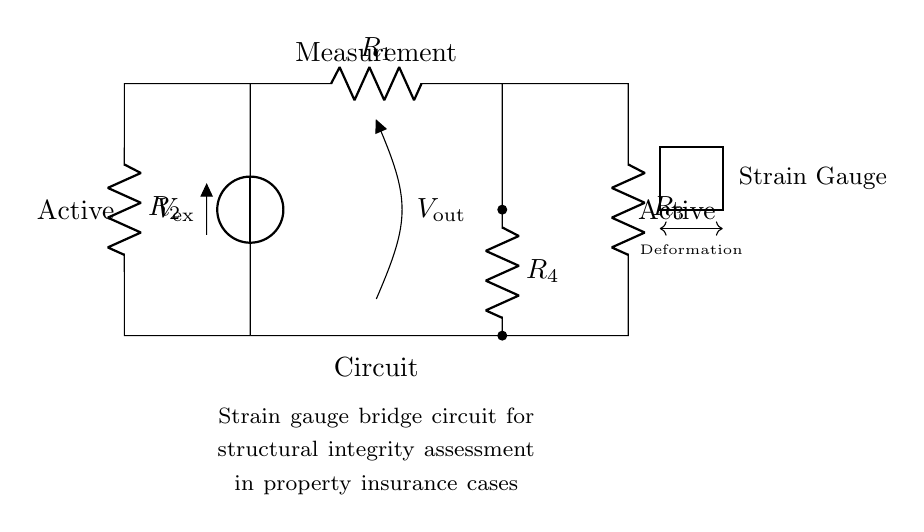What is the value of the voltage source? The voltage source is labeled as V_ex, but the specific value is not given in the diagram. It represents the external voltage applied to the circuit.
Answer: V_ex How many resistors are present in this circuit? There are four resistors labeled R1, R2, R3, and R4 connected in the circuit, which makes a total of four resistors present.
Answer: 4 Which components are in the active arm of the bridge? The active arm of the bridge includes the strain gauge and the resistors R3 and R4, as they directly participate in measuring the strain.
Answer: Strain gauge, R3, R4 What is the function of the voltmeter in the circuit? The voltmeter measures the voltage output, V_out, which indicates the difference in potential due to the strain measured by the strain gauge.
Answer: Measure voltage output What happens to the output voltage if the strain gauge deforms? If the strain gauge deforms, it changes its resistance, which alters the voltage balance in the bridge circuit leading to a change in the output voltage, V_out.
Answer: Changes output voltage What type of circuit configuration is used in this diagram? This diagram represents a Wheatstone bridge configuration, commonly used for precise measurement of resistance changes in strain gauges.
Answer: Wheatstone bridge What does the measurement circuit indicate? The measurement circuit indicates the condition of structural integrity as related to the applied strain, which can impact insurance assessments for property.
Answer: Structural integrity assessment 